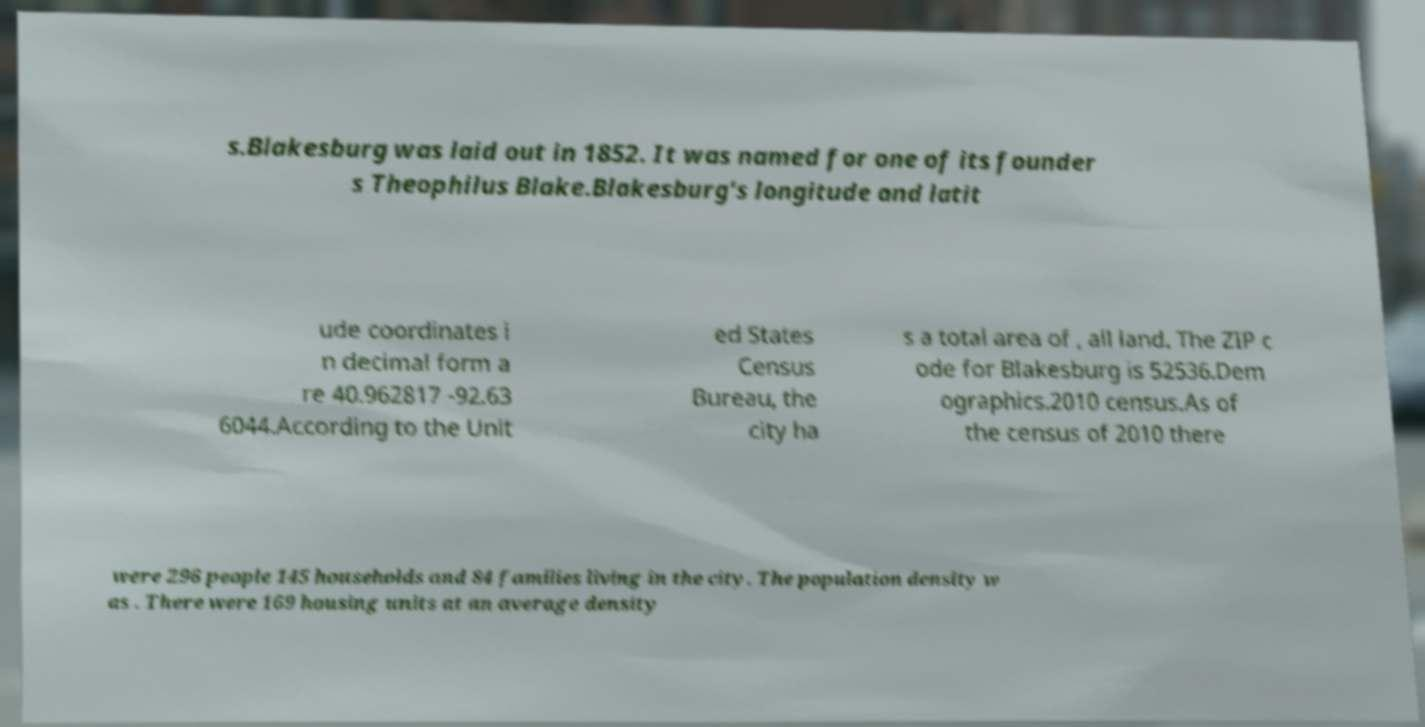Please identify and transcribe the text found in this image. s.Blakesburg was laid out in 1852. It was named for one of its founder s Theophilus Blake.Blakesburg's longitude and latit ude coordinates i n decimal form a re 40.962817 -92.63 6044.According to the Unit ed States Census Bureau, the city ha s a total area of , all land. The ZIP c ode for Blakesburg is 52536.Dem ographics.2010 census.As of the census of 2010 there were 296 people 145 households and 84 families living in the city. The population density w as . There were 169 housing units at an average density 